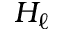<formula> <loc_0><loc_0><loc_500><loc_500>H _ { \ell }</formula> 